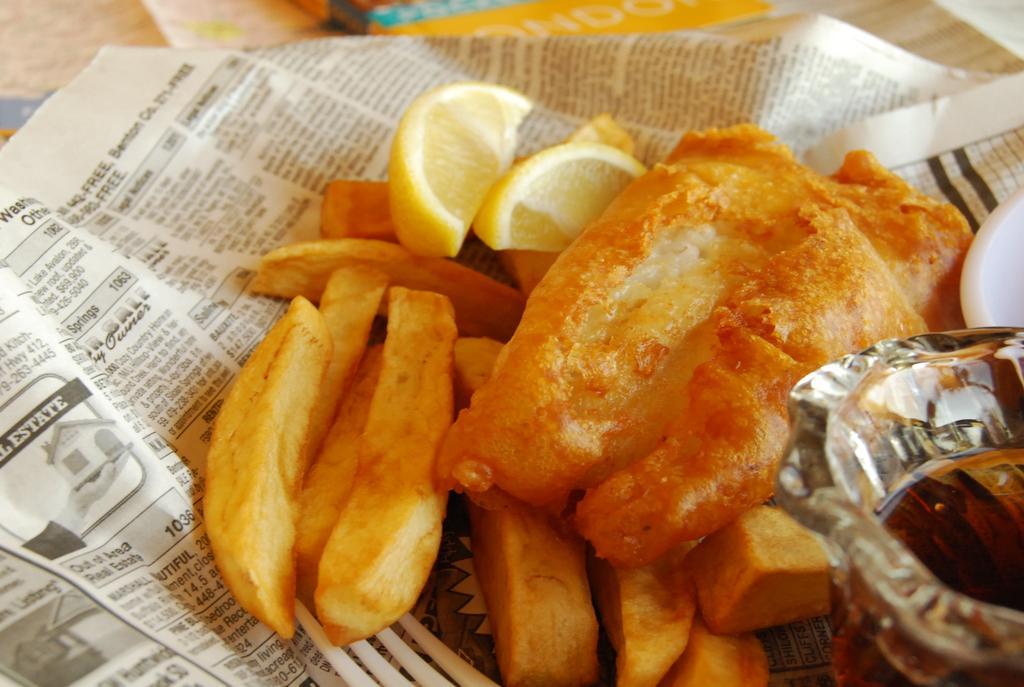<image>
Create a compact narrative representing the image presented. The word Estate can be seen to the left on the paper the fish and chips are sitting on. 